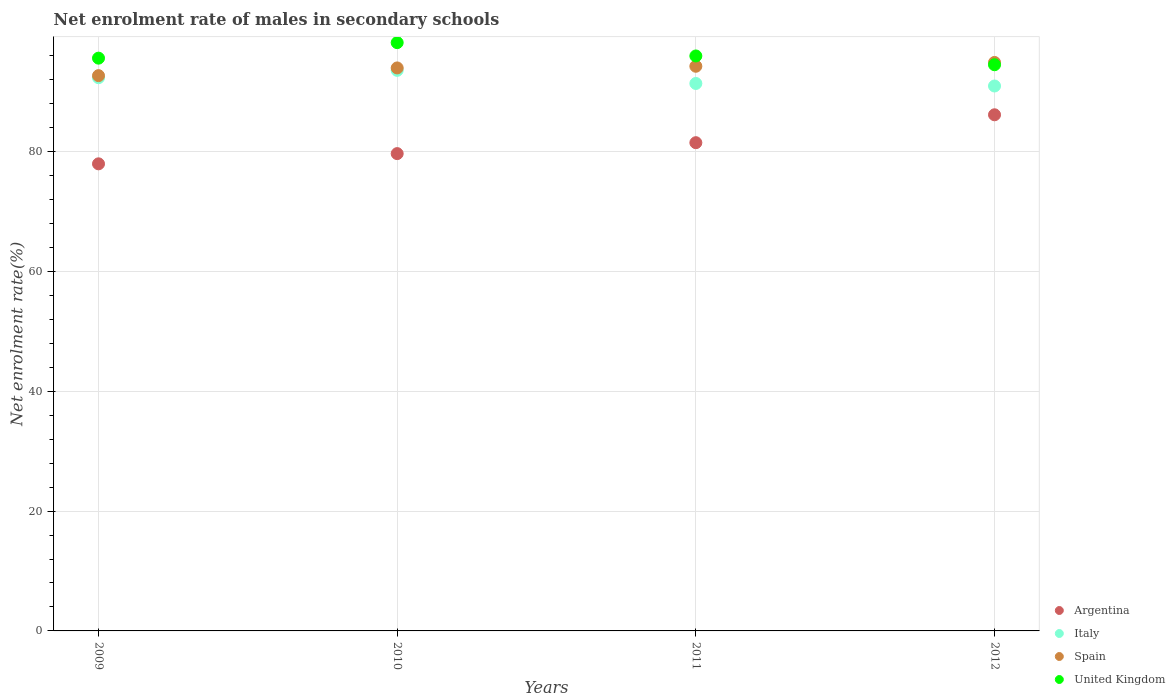How many different coloured dotlines are there?
Your answer should be compact. 4. Is the number of dotlines equal to the number of legend labels?
Your answer should be compact. Yes. What is the net enrolment rate of males in secondary schools in United Kingdom in 2011?
Offer a very short reply. 95.97. Across all years, what is the maximum net enrolment rate of males in secondary schools in Spain?
Your response must be concise. 94.89. Across all years, what is the minimum net enrolment rate of males in secondary schools in Spain?
Provide a short and direct response. 92.68. In which year was the net enrolment rate of males in secondary schools in Argentina maximum?
Provide a succinct answer. 2012. In which year was the net enrolment rate of males in secondary schools in Spain minimum?
Ensure brevity in your answer.  2009. What is the total net enrolment rate of males in secondary schools in United Kingdom in the graph?
Provide a short and direct response. 384.27. What is the difference between the net enrolment rate of males in secondary schools in Italy in 2010 and that in 2012?
Provide a succinct answer. 2.61. What is the difference between the net enrolment rate of males in secondary schools in Argentina in 2011 and the net enrolment rate of males in secondary schools in Spain in 2010?
Make the answer very short. -12.48. What is the average net enrolment rate of males in secondary schools in Italy per year?
Provide a succinct answer. 92.06. In the year 2011, what is the difference between the net enrolment rate of males in secondary schools in Spain and net enrolment rate of males in secondary schools in United Kingdom?
Keep it short and to the point. -1.72. What is the ratio of the net enrolment rate of males in secondary schools in Italy in 2011 to that in 2012?
Provide a short and direct response. 1. Is the net enrolment rate of males in secondary schools in Spain in 2009 less than that in 2012?
Provide a short and direct response. Yes. Is the difference between the net enrolment rate of males in secondary schools in Spain in 2009 and 2011 greater than the difference between the net enrolment rate of males in secondary schools in United Kingdom in 2009 and 2011?
Your answer should be compact. No. What is the difference between the highest and the second highest net enrolment rate of males in secondary schools in Spain?
Keep it short and to the point. 0.64. What is the difference between the highest and the lowest net enrolment rate of males in secondary schools in Argentina?
Your answer should be compact. 8.19. Is it the case that in every year, the sum of the net enrolment rate of males in secondary schools in Italy and net enrolment rate of males in secondary schools in Spain  is greater than the net enrolment rate of males in secondary schools in Argentina?
Your answer should be compact. Yes. Does the net enrolment rate of males in secondary schools in Italy monotonically increase over the years?
Make the answer very short. No. How many dotlines are there?
Provide a short and direct response. 4. What is the difference between two consecutive major ticks on the Y-axis?
Give a very brief answer. 20. Are the values on the major ticks of Y-axis written in scientific E-notation?
Keep it short and to the point. No. Does the graph contain any zero values?
Offer a terse response. No. Does the graph contain grids?
Keep it short and to the point. Yes. Where does the legend appear in the graph?
Ensure brevity in your answer.  Bottom right. How are the legend labels stacked?
Offer a very short reply. Vertical. What is the title of the graph?
Offer a terse response. Net enrolment rate of males in secondary schools. What is the label or title of the X-axis?
Provide a succinct answer. Years. What is the label or title of the Y-axis?
Provide a short and direct response. Net enrolment rate(%). What is the Net enrolment rate(%) in Argentina in 2009?
Provide a succinct answer. 77.97. What is the Net enrolment rate(%) in Italy in 2009?
Your answer should be very brief. 92.34. What is the Net enrolment rate(%) of Spain in 2009?
Offer a terse response. 92.68. What is the Net enrolment rate(%) of United Kingdom in 2009?
Keep it short and to the point. 95.6. What is the Net enrolment rate(%) in Argentina in 2010?
Your response must be concise. 79.67. What is the Net enrolment rate(%) of Italy in 2010?
Make the answer very short. 93.57. What is the Net enrolment rate(%) in Spain in 2010?
Provide a short and direct response. 93.97. What is the Net enrolment rate(%) in United Kingdom in 2010?
Your response must be concise. 98.2. What is the Net enrolment rate(%) of Argentina in 2011?
Ensure brevity in your answer.  81.49. What is the Net enrolment rate(%) of Italy in 2011?
Make the answer very short. 91.38. What is the Net enrolment rate(%) in Spain in 2011?
Make the answer very short. 94.25. What is the Net enrolment rate(%) in United Kingdom in 2011?
Your answer should be compact. 95.97. What is the Net enrolment rate(%) in Argentina in 2012?
Offer a very short reply. 86.15. What is the Net enrolment rate(%) of Italy in 2012?
Provide a short and direct response. 90.96. What is the Net enrolment rate(%) in Spain in 2012?
Offer a very short reply. 94.89. What is the Net enrolment rate(%) of United Kingdom in 2012?
Give a very brief answer. 94.5. Across all years, what is the maximum Net enrolment rate(%) of Argentina?
Your answer should be compact. 86.15. Across all years, what is the maximum Net enrolment rate(%) in Italy?
Give a very brief answer. 93.57. Across all years, what is the maximum Net enrolment rate(%) in Spain?
Offer a terse response. 94.89. Across all years, what is the maximum Net enrolment rate(%) of United Kingdom?
Your answer should be compact. 98.2. Across all years, what is the minimum Net enrolment rate(%) of Argentina?
Offer a terse response. 77.97. Across all years, what is the minimum Net enrolment rate(%) in Italy?
Give a very brief answer. 90.96. Across all years, what is the minimum Net enrolment rate(%) of Spain?
Ensure brevity in your answer.  92.68. Across all years, what is the minimum Net enrolment rate(%) of United Kingdom?
Offer a terse response. 94.5. What is the total Net enrolment rate(%) in Argentina in the graph?
Your answer should be compact. 325.28. What is the total Net enrolment rate(%) of Italy in the graph?
Keep it short and to the point. 368.24. What is the total Net enrolment rate(%) of Spain in the graph?
Offer a terse response. 375.79. What is the total Net enrolment rate(%) in United Kingdom in the graph?
Your answer should be compact. 384.27. What is the difference between the Net enrolment rate(%) in Argentina in 2009 and that in 2010?
Provide a short and direct response. -1.71. What is the difference between the Net enrolment rate(%) in Italy in 2009 and that in 2010?
Provide a short and direct response. -1.23. What is the difference between the Net enrolment rate(%) in Spain in 2009 and that in 2010?
Your answer should be compact. -1.29. What is the difference between the Net enrolment rate(%) of United Kingdom in 2009 and that in 2010?
Your response must be concise. -2.59. What is the difference between the Net enrolment rate(%) of Argentina in 2009 and that in 2011?
Keep it short and to the point. -3.53. What is the difference between the Net enrolment rate(%) in Spain in 2009 and that in 2011?
Keep it short and to the point. -1.57. What is the difference between the Net enrolment rate(%) in United Kingdom in 2009 and that in 2011?
Your answer should be compact. -0.37. What is the difference between the Net enrolment rate(%) in Argentina in 2009 and that in 2012?
Your answer should be compact. -8.19. What is the difference between the Net enrolment rate(%) in Italy in 2009 and that in 2012?
Make the answer very short. 1.38. What is the difference between the Net enrolment rate(%) in Spain in 2009 and that in 2012?
Give a very brief answer. -2.2. What is the difference between the Net enrolment rate(%) in United Kingdom in 2009 and that in 2012?
Your answer should be very brief. 1.1. What is the difference between the Net enrolment rate(%) in Argentina in 2010 and that in 2011?
Offer a terse response. -1.82. What is the difference between the Net enrolment rate(%) in Italy in 2010 and that in 2011?
Offer a very short reply. 2.19. What is the difference between the Net enrolment rate(%) of Spain in 2010 and that in 2011?
Offer a very short reply. -0.28. What is the difference between the Net enrolment rate(%) in United Kingdom in 2010 and that in 2011?
Your response must be concise. 2.23. What is the difference between the Net enrolment rate(%) of Argentina in 2010 and that in 2012?
Your response must be concise. -6.48. What is the difference between the Net enrolment rate(%) of Italy in 2010 and that in 2012?
Give a very brief answer. 2.61. What is the difference between the Net enrolment rate(%) in Spain in 2010 and that in 2012?
Your response must be concise. -0.92. What is the difference between the Net enrolment rate(%) in United Kingdom in 2010 and that in 2012?
Your response must be concise. 3.69. What is the difference between the Net enrolment rate(%) in Argentina in 2011 and that in 2012?
Your answer should be compact. -4.66. What is the difference between the Net enrolment rate(%) in Italy in 2011 and that in 2012?
Ensure brevity in your answer.  0.42. What is the difference between the Net enrolment rate(%) of Spain in 2011 and that in 2012?
Your response must be concise. -0.64. What is the difference between the Net enrolment rate(%) in United Kingdom in 2011 and that in 2012?
Give a very brief answer. 1.47. What is the difference between the Net enrolment rate(%) of Argentina in 2009 and the Net enrolment rate(%) of Italy in 2010?
Your answer should be very brief. -15.6. What is the difference between the Net enrolment rate(%) in Argentina in 2009 and the Net enrolment rate(%) in Spain in 2010?
Provide a succinct answer. -16.01. What is the difference between the Net enrolment rate(%) of Argentina in 2009 and the Net enrolment rate(%) of United Kingdom in 2010?
Offer a very short reply. -20.23. What is the difference between the Net enrolment rate(%) in Italy in 2009 and the Net enrolment rate(%) in Spain in 2010?
Your response must be concise. -1.63. What is the difference between the Net enrolment rate(%) in Italy in 2009 and the Net enrolment rate(%) in United Kingdom in 2010?
Give a very brief answer. -5.86. What is the difference between the Net enrolment rate(%) of Spain in 2009 and the Net enrolment rate(%) of United Kingdom in 2010?
Offer a very short reply. -5.51. What is the difference between the Net enrolment rate(%) in Argentina in 2009 and the Net enrolment rate(%) in Italy in 2011?
Offer a very short reply. -13.41. What is the difference between the Net enrolment rate(%) of Argentina in 2009 and the Net enrolment rate(%) of Spain in 2011?
Give a very brief answer. -16.29. What is the difference between the Net enrolment rate(%) of Argentina in 2009 and the Net enrolment rate(%) of United Kingdom in 2011?
Your answer should be compact. -18. What is the difference between the Net enrolment rate(%) of Italy in 2009 and the Net enrolment rate(%) of Spain in 2011?
Your answer should be compact. -1.91. What is the difference between the Net enrolment rate(%) of Italy in 2009 and the Net enrolment rate(%) of United Kingdom in 2011?
Keep it short and to the point. -3.63. What is the difference between the Net enrolment rate(%) in Spain in 2009 and the Net enrolment rate(%) in United Kingdom in 2011?
Your answer should be very brief. -3.29. What is the difference between the Net enrolment rate(%) in Argentina in 2009 and the Net enrolment rate(%) in Italy in 2012?
Give a very brief answer. -12.99. What is the difference between the Net enrolment rate(%) of Argentina in 2009 and the Net enrolment rate(%) of Spain in 2012?
Your response must be concise. -16.92. What is the difference between the Net enrolment rate(%) in Argentina in 2009 and the Net enrolment rate(%) in United Kingdom in 2012?
Provide a short and direct response. -16.54. What is the difference between the Net enrolment rate(%) of Italy in 2009 and the Net enrolment rate(%) of Spain in 2012?
Provide a succinct answer. -2.55. What is the difference between the Net enrolment rate(%) of Italy in 2009 and the Net enrolment rate(%) of United Kingdom in 2012?
Give a very brief answer. -2.17. What is the difference between the Net enrolment rate(%) of Spain in 2009 and the Net enrolment rate(%) of United Kingdom in 2012?
Make the answer very short. -1.82. What is the difference between the Net enrolment rate(%) in Argentina in 2010 and the Net enrolment rate(%) in Italy in 2011?
Give a very brief answer. -11.71. What is the difference between the Net enrolment rate(%) of Argentina in 2010 and the Net enrolment rate(%) of Spain in 2011?
Ensure brevity in your answer.  -14.58. What is the difference between the Net enrolment rate(%) in Argentina in 2010 and the Net enrolment rate(%) in United Kingdom in 2011?
Give a very brief answer. -16.3. What is the difference between the Net enrolment rate(%) in Italy in 2010 and the Net enrolment rate(%) in Spain in 2011?
Offer a very short reply. -0.68. What is the difference between the Net enrolment rate(%) of Italy in 2010 and the Net enrolment rate(%) of United Kingdom in 2011?
Your answer should be very brief. -2.4. What is the difference between the Net enrolment rate(%) in Spain in 2010 and the Net enrolment rate(%) in United Kingdom in 2011?
Your response must be concise. -2. What is the difference between the Net enrolment rate(%) of Argentina in 2010 and the Net enrolment rate(%) of Italy in 2012?
Ensure brevity in your answer.  -11.29. What is the difference between the Net enrolment rate(%) of Argentina in 2010 and the Net enrolment rate(%) of Spain in 2012?
Make the answer very short. -15.22. What is the difference between the Net enrolment rate(%) of Argentina in 2010 and the Net enrolment rate(%) of United Kingdom in 2012?
Ensure brevity in your answer.  -14.83. What is the difference between the Net enrolment rate(%) of Italy in 2010 and the Net enrolment rate(%) of Spain in 2012?
Offer a very short reply. -1.32. What is the difference between the Net enrolment rate(%) of Italy in 2010 and the Net enrolment rate(%) of United Kingdom in 2012?
Keep it short and to the point. -0.94. What is the difference between the Net enrolment rate(%) of Spain in 2010 and the Net enrolment rate(%) of United Kingdom in 2012?
Your response must be concise. -0.53. What is the difference between the Net enrolment rate(%) of Argentina in 2011 and the Net enrolment rate(%) of Italy in 2012?
Give a very brief answer. -9.46. What is the difference between the Net enrolment rate(%) of Argentina in 2011 and the Net enrolment rate(%) of Spain in 2012?
Offer a very short reply. -13.39. What is the difference between the Net enrolment rate(%) in Argentina in 2011 and the Net enrolment rate(%) in United Kingdom in 2012?
Your response must be concise. -13.01. What is the difference between the Net enrolment rate(%) of Italy in 2011 and the Net enrolment rate(%) of Spain in 2012?
Offer a terse response. -3.51. What is the difference between the Net enrolment rate(%) in Italy in 2011 and the Net enrolment rate(%) in United Kingdom in 2012?
Make the answer very short. -3.13. What is the difference between the Net enrolment rate(%) in Spain in 2011 and the Net enrolment rate(%) in United Kingdom in 2012?
Provide a short and direct response. -0.25. What is the average Net enrolment rate(%) of Argentina per year?
Your answer should be compact. 81.32. What is the average Net enrolment rate(%) in Italy per year?
Your response must be concise. 92.06. What is the average Net enrolment rate(%) of Spain per year?
Your answer should be very brief. 93.95. What is the average Net enrolment rate(%) of United Kingdom per year?
Your response must be concise. 96.07. In the year 2009, what is the difference between the Net enrolment rate(%) of Argentina and Net enrolment rate(%) of Italy?
Ensure brevity in your answer.  -14.37. In the year 2009, what is the difference between the Net enrolment rate(%) of Argentina and Net enrolment rate(%) of Spain?
Make the answer very short. -14.72. In the year 2009, what is the difference between the Net enrolment rate(%) in Argentina and Net enrolment rate(%) in United Kingdom?
Give a very brief answer. -17.64. In the year 2009, what is the difference between the Net enrolment rate(%) in Italy and Net enrolment rate(%) in Spain?
Your response must be concise. -0.35. In the year 2009, what is the difference between the Net enrolment rate(%) of Italy and Net enrolment rate(%) of United Kingdom?
Provide a succinct answer. -3.27. In the year 2009, what is the difference between the Net enrolment rate(%) in Spain and Net enrolment rate(%) in United Kingdom?
Make the answer very short. -2.92. In the year 2010, what is the difference between the Net enrolment rate(%) of Argentina and Net enrolment rate(%) of Italy?
Your response must be concise. -13.9. In the year 2010, what is the difference between the Net enrolment rate(%) in Argentina and Net enrolment rate(%) in Spain?
Keep it short and to the point. -14.3. In the year 2010, what is the difference between the Net enrolment rate(%) of Argentina and Net enrolment rate(%) of United Kingdom?
Your answer should be very brief. -18.52. In the year 2010, what is the difference between the Net enrolment rate(%) in Italy and Net enrolment rate(%) in Spain?
Provide a short and direct response. -0.4. In the year 2010, what is the difference between the Net enrolment rate(%) in Italy and Net enrolment rate(%) in United Kingdom?
Keep it short and to the point. -4.63. In the year 2010, what is the difference between the Net enrolment rate(%) in Spain and Net enrolment rate(%) in United Kingdom?
Make the answer very short. -4.22. In the year 2011, what is the difference between the Net enrolment rate(%) of Argentina and Net enrolment rate(%) of Italy?
Provide a short and direct response. -9.88. In the year 2011, what is the difference between the Net enrolment rate(%) of Argentina and Net enrolment rate(%) of Spain?
Give a very brief answer. -12.76. In the year 2011, what is the difference between the Net enrolment rate(%) in Argentina and Net enrolment rate(%) in United Kingdom?
Your answer should be compact. -14.48. In the year 2011, what is the difference between the Net enrolment rate(%) of Italy and Net enrolment rate(%) of Spain?
Provide a short and direct response. -2.87. In the year 2011, what is the difference between the Net enrolment rate(%) of Italy and Net enrolment rate(%) of United Kingdom?
Keep it short and to the point. -4.59. In the year 2011, what is the difference between the Net enrolment rate(%) in Spain and Net enrolment rate(%) in United Kingdom?
Ensure brevity in your answer.  -1.72. In the year 2012, what is the difference between the Net enrolment rate(%) of Argentina and Net enrolment rate(%) of Italy?
Provide a succinct answer. -4.8. In the year 2012, what is the difference between the Net enrolment rate(%) of Argentina and Net enrolment rate(%) of Spain?
Give a very brief answer. -8.74. In the year 2012, what is the difference between the Net enrolment rate(%) in Argentina and Net enrolment rate(%) in United Kingdom?
Provide a succinct answer. -8.35. In the year 2012, what is the difference between the Net enrolment rate(%) in Italy and Net enrolment rate(%) in Spain?
Your response must be concise. -3.93. In the year 2012, what is the difference between the Net enrolment rate(%) in Italy and Net enrolment rate(%) in United Kingdom?
Provide a succinct answer. -3.55. In the year 2012, what is the difference between the Net enrolment rate(%) of Spain and Net enrolment rate(%) of United Kingdom?
Give a very brief answer. 0.38. What is the ratio of the Net enrolment rate(%) in Argentina in 2009 to that in 2010?
Make the answer very short. 0.98. What is the ratio of the Net enrolment rate(%) in Italy in 2009 to that in 2010?
Offer a very short reply. 0.99. What is the ratio of the Net enrolment rate(%) of Spain in 2009 to that in 2010?
Your response must be concise. 0.99. What is the ratio of the Net enrolment rate(%) of United Kingdom in 2009 to that in 2010?
Provide a short and direct response. 0.97. What is the ratio of the Net enrolment rate(%) in Argentina in 2009 to that in 2011?
Give a very brief answer. 0.96. What is the ratio of the Net enrolment rate(%) of Italy in 2009 to that in 2011?
Your response must be concise. 1.01. What is the ratio of the Net enrolment rate(%) of Spain in 2009 to that in 2011?
Ensure brevity in your answer.  0.98. What is the ratio of the Net enrolment rate(%) of Argentina in 2009 to that in 2012?
Your answer should be very brief. 0.91. What is the ratio of the Net enrolment rate(%) in Italy in 2009 to that in 2012?
Your answer should be compact. 1.02. What is the ratio of the Net enrolment rate(%) of Spain in 2009 to that in 2012?
Offer a terse response. 0.98. What is the ratio of the Net enrolment rate(%) of United Kingdom in 2009 to that in 2012?
Ensure brevity in your answer.  1.01. What is the ratio of the Net enrolment rate(%) in Argentina in 2010 to that in 2011?
Your answer should be compact. 0.98. What is the ratio of the Net enrolment rate(%) in Italy in 2010 to that in 2011?
Ensure brevity in your answer.  1.02. What is the ratio of the Net enrolment rate(%) in United Kingdom in 2010 to that in 2011?
Your response must be concise. 1.02. What is the ratio of the Net enrolment rate(%) in Argentina in 2010 to that in 2012?
Ensure brevity in your answer.  0.92. What is the ratio of the Net enrolment rate(%) of Italy in 2010 to that in 2012?
Ensure brevity in your answer.  1.03. What is the ratio of the Net enrolment rate(%) in Spain in 2010 to that in 2012?
Your answer should be very brief. 0.99. What is the ratio of the Net enrolment rate(%) in United Kingdom in 2010 to that in 2012?
Your response must be concise. 1.04. What is the ratio of the Net enrolment rate(%) in Argentina in 2011 to that in 2012?
Offer a terse response. 0.95. What is the ratio of the Net enrolment rate(%) in Italy in 2011 to that in 2012?
Your response must be concise. 1. What is the ratio of the Net enrolment rate(%) of Spain in 2011 to that in 2012?
Offer a very short reply. 0.99. What is the ratio of the Net enrolment rate(%) of United Kingdom in 2011 to that in 2012?
Your response must be concise. 1.02. What is the difference between the highest and the second highest Net enrolment rate(%) in Argentina?
Your answer should be compact. 4.66. What is the difference between the highest and the second highest Net enrolment rate(%) in Italy?
Give a very brief answer. 1.23. What is the difference between the highest and the second highest Net enrolment rate(%) of Spain?
Your answer should be compact. 0.64. What is the difference between the highest and the second highest Net enrolment rate(%) of United Kingdom?
Provide a succinct answer. 2.23. What is the difference between the highest and the lowest Net enrolment rate(%) of Argentina?
Make the answer very short. 8.19. What is the difference between the highest and the lowest Net enrolment rate(%) of Italy?
Keep it short and to the point. 2.61. What is the difference between the highest and the lowest Net enrolment rate(%) in Spain?
Offer a very short reply. 2.2. What is the difference between the highest and the lowest Net enrolment rate(%) of United Kingdom?
Keep it short and to the point. 3.69. 